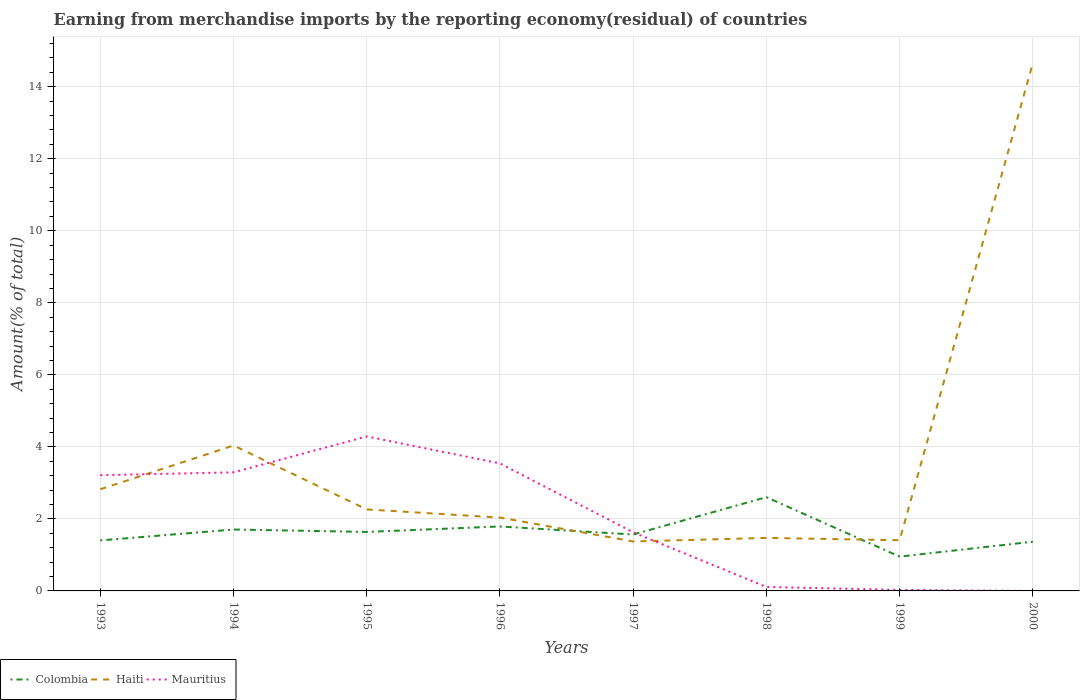How many different coloured lines are there?
Ensure brevity in your answer.  3. Is the number of lines equal to the number of legend labels?
Your response must be concise. Yes. Across all years, what is the maximum percentage of amount earned from merchandise imports in Haiti?
Provide a succinct answer. 1.37. What is the total percentage of amount earned from merchandise imports in Colombia in the graph?
Keep it short and to the point. -1.04. What is the difference between the highest and the second highest percentage of amount earned from merchandise imports in Colombia?
Offer a very short reply. 1.65. What is the difference between the highest and the lowest percentage of amount earned from merchandise imports in Haiti?
Provide a short and direct response. 2. How many years are there in the graph?
Provide a short and direct response. 8. Does the graph contain grids?
Make the answer very short. Yes. Where does the legend appear in the graph?
Your answer should be compact. Bottom left. How many legend labels are there?
Give a very brief answer. 3. How are the legend labels stacked?
Give a very brief answer. Horizontal. What is the title of the graph?
Ensure brevity in your answer.  Earning from merchandise imports by the reporting economy(residual) of countries. What is the label or title of the X-axis?
Your answer should be very brief. Years. What is the label or title of the Y-axis?
Your response must be concise. Amount(% of total). What is the Amount(% of total) in Colombia in 1993?
Your response must be concise. 1.4. What is the Amount(% of total) of Haiti in 1993?
Offer a terse response. 2.82. What is the Amount(% of total) of Mauritius in 1993?
Give a very brief answer. 3.21. What is the Amount(% of total) of Colombia in 1994?
Give a very brief answer. 1.71. What is the Amount(% of total) of Haiti in 1994?
Your answer should be compact. 4.04. What is the Amount(% of total) of Mauritius in 1994?
Offer a very short reply. 3.29. What is the Amount(% of total) of Colombia in 1995?
Keep it short and to the point. 1.64. What is the Amount(% of total) of Haiti in 1995?
Ensure brevity in your answer.  2.26. What is the Amount(% of total) of Mauritius in 1995?
Ensure brevity in your answer.  4.29. What is the Amount(% of total) in Colombia in 1996?
Your answer should be compact. 1.79. What is the Amount(% of total) in Haiti in 1996?
Give a very brief answer. 2.04. What is the Amount(% of total) of Mauritius in 1996?
Keep it short and to the point. 3.54. What is the Amount(% of total) of Colombia in 1997?
Make the answer very short. 1.57. What is the Amount(% of total) of Haiti in 1997?
Offer a very short reply. 1.37. What is the Amount(% of total) of Mauritius in 1997?
Give a very brief answer. 1.63. What is the Amount(% of total) of Colombia in 1998?
Your answer should be compact. 2.6. What is the Amount(% of total) in Haiti in 1998?
Your answer should be very brief. 1.47. What is the Amount(% of total) of Mauritius in 1998?
Provide a short and direct response. 0.11. What is the Amount(% of total) of Colombia in 1999?
Provide a succinct answer. 0.95. What is the Amount(% of total) of Haiti in 1999?
Make the answer very short. 1.41. What is the Amount(% of total) in Mauritius in 1999?
Your answer should be compact. 0.03. What is the Amount(% of total) of Colombia in 2000?
Your answer should be very brief. 1.37. What is the Amount(% of total) of Haiti in 2000?
Your answer should be compact. 14.66. What is the Amount(% of total) of Mauritius in 2000?
Your response must be concise. 0. Across all years, what is the maximum Amount(% of total) of Colombia?
Your answer should be compact. 2.6. Across all years, what is the maximum Amount(% of total) in Haiti?
Your response must be concise. 14.66. Across all years, what is the maximum Amount(% of total) of Mauritius?
Offer a terse response. 4.29. Across all years, what is the minimum Amount(% of total) of Colombia?
Your response must be concise. 0.95. Across all years, what is the minimum Amount(% of total) in Haiti?
Offer a terse response. 1.37. Across all years, what is the minimum Amount(% of total) in Mauritius?
Offer a terse response. 0. What is the total Amount(% of total) in Colombia in the graph?
Your answer should be very brief. 13.02. What is the total Amount(% of total) in Haiti in the graph?
Your answer should be compact. 30.07. What is the total Amount(% of total) of Mauritius in the graph?
Ensure brevity in your answer.  16.1. What is the difference between the Amount(% of total) of Colombia in 1993 and that in 1994?
Give a very brief answer. -0.3. What is the difference between the Amount(% of total) in Haiti in 1993 and that in 1994?
Make the answer very short. -1.22. What is the difference between the Amount(% of total) of Mauritius in 1993 and that in 1994?
Your response must be concise. -0.08. What is the difference between the Amount(% of total) of Colombia in 1993 and that in 1995?
Make the answer very short. -0.24. What is the difference between the Amount(% of total) of Haiti in 1993 and that in 1995?
Offer a very short reply. 0.56. What is the difference between the Amount(% of total) of Mauritius in 1993 and that in 1995?
Your answer should be very brief. -1.08. What is the difference between the Amount(% of total) in Colombia in 1993 and that in 1996?
Provide a short and direct response. -0.39. What is the difference between the Amount(% of total) of Haiti in 1993 and that in 1996?
Provide a succinct answer. 0.79. What is the difference between the Amount(% of total) in Mauritius in 1993 and that in 1996?
Ensure brevity in your answer.  -0.33. What is the difference between the Amount(% of total) in Colombia in 1993 and that in 1997?
Offer a terse response. -0.16. What is the difference between the Amount(% of total) in Haiti in 1993 and that in 1997?
Give a very brief answer. 1.45. What is the difference between the Amount(% of total) of Mauritius in 1993 and that in 1997?
Give a very brief answer. 1.59. What is the difference between the Amount(% of total) of Colombia in 1993 and that in 1998?
Your answer should be very brief. -1.2. What is the difference between the Amount(% of total) of Haiti in 1993 and that in 1998?
Offer a terse response. 1.35. What is the difference between the Amount(% of total) of Mauritius in 1993 and that in 1998?
Offer a terse response. 3.1. What is the difference between the Amount(% of total) in Colombia in 1993 and that in 1999?
Your answer should be very brief. 0.45. What is the difference between the Amount(% of total) in Haiti in 1993 and that in 1999?
Your answer should be compact. 1.42. What is the difference between the Amount(% of total) in Mauritius in 1993 and that in 1999?
Your answer should be very brief. 3.19. What is the difference between the Amount(% of total) in Colombia in 1993 and that in 2000?
Your answer should be very brief. 0.04. What is the difference between the Amount(% of total) in Haiti in 1993 and that in 2000?
Ensure brevity in your answer.  -11.84. What is the difference between the Amount(% of total) of Mauritius in 1993 and that in 2000?
Your answer should be compact. 3.21. What is the difference between the Amount(% of total) of Colombia in 1994 and that in 1995?
Ensure brevity in your answer.  0.07. What is the difference between the Amount(% of total) of Haiti in 1994 and that in 1995?
Keep it short and to the point. 1.78. What is the difference between the Amount(% of total) of Mauritius in 1994 and that in 1995?
Ensure brevity in your answer.  -1. What is the difference between the Amount(% of total) of Colombia in 1994 and that in 1996?
Provide a short and direct response. -0.08. What is the difference between the Amount(% of total) of Haiti in 1994 and that in 1996?
Keep it short and to the point. 2. What is the difference between the Amount(% of total) of Mauritius in 1994 and that in 1996?
Give a very brief answer. -0.25. What is the difference between the Amount(% of total) in Colombia in 1994 and that in 1997?
Provide a short and direct response. 0.14. What is the difference between the Amount(% of total) in Haiti in 1994 and that in 1997?
Provide a short and direct response. 2.67. What is the difference between the Amount(% of total) in Mauritius in 1994 and that in 1997?
Make the answer very short. 1.66. What is the difference between the Amount(% of total) of Colombia in 1994 and that in 1998?
Offer a very short reply. -0.9. What is the difference between the Amount(% of total) in Haiti in 1994 and that in 1998?
Keep it short and to the point. 2.57. What is the difference between the Amount(% of total) of Mauritius in 1994 and that in 1998?
Provide a succinct answer. 3.18. What is the difference between the Amount(% of total) in Colombia in 1994 and that in 1999?
Keep it short and to the point. 0.75. What is the difference between the Amount(% of total) in Haiti in 1994 and that in 1999?
Offer a very short reply. 2.63. What is the difference between the Amount(% of total) of Mauritius in 1994 and that in 1999?
Make the answer very short. 3.26. What is the difference between the Amount(% of total) of Colombia in 1994 and that in 2000?
Offer a terse response. 0.34. What is the difference between the Amount(% of total) of Haiti in 1994 and that in 2000?
Your response must be concise. -10.62. What is the difference between the Amount(% of total) of Mauritius in 1994 and that in 2000?
Give a very brief answer. 3.29. What is the difference between the Amount(% of total) in Colombia in 1995 and that in 1996?
Ensure brevity in your answer.  -0.15. What is the difference between the Amount(% of total) in Haiti in 1995 and that in 1996?
Offer a terse response. 0.23. What is the difference between the Amount(% of total) of Mauritius in 1995 and that in 1996?
Offer a very short reply. 0.75. What is the difference between the Amount(% of total) in Colombia in 1995 and that in 1997?
Provide a short and direct response. 0.07. What is the difference between the Amount(% of total) in Haiti in 1995 and that in 1997?
Offer a terse response. 0.89. What is the difference between the Amount(% of total) of Mauritius in 1995 and that in 1997?
Keep it short and to the point. 2.66. What is the difference between the Amount(% of total) of Colombia in 1995 and that in 1998?
Your response must be concise. -0.96. What is the difference between the Amount(% of total) of Haiti in 1995 and that in 1998?
Make the answer very short. 0.79. What is the difference between the Amount(% of total) in Mauritius in 1995 and that in 1998?
Your answer should be very brief. 4.18. What is the difference between the Amount(% of total) of Colombia in 1995 and that in 1999?
Offer a very short reply. 0.69. What is the difference between the Amount(% of total) in Haiti in 1995 and that in 1999?
Your response must be concise. 0.85. What is the difference between the Amount(% of total) in Mauritius in 1995 and that in 1999?
Offer a terse response. 4.26. What is the difference between the Amount(% of total) in Colombia in 1995 and that in 2000?
Keep it short and to the point. 0.27. What is the difference between the Amount(% of total) in Haiti in 1995 and that in 2000?
Your response must be concise. -12.4. What is the difference between the Amount(% of total) of Mauritius in 1995 and that in 2000?
Your response must be concise. 4.29. What is the difference between the Amount(% of total) of Colombia in 1996 and that in 1997?
Your answer should be very brief. 0.22. What is the difference between the Amount(% of total) in Haiti in 1996 and that in 1997?
Your response must be concise. 0.66. What is the difference between the Amount(% of total) in Mauritius in 1996 and that in 1997?
Offer a terse response. 1.91. What is the difference between the Amount(% of total) of Colombia in 1996 and that in 1998?
Ensure brevity in your answer.  -0.81. What is the difference between the Amount(% of total) of Haiti in 1996 and that in 1998?
Offer a terse response. 0.56. What is the difference between the Amount(% of total) of Mauritius in 1996 and that in 1998?
Offer a very short reply. 3.43. What is the difference between the Amount(% of total) of Colombia in 1996 and that in 1999?
Your response must be concise. 0.84. What is the difference between the Amount(% of total) in Haiti in 1996 and that in 1999?
Keep it short and to the point. 0.63. What is the difference between the Amount(% of total) in Mauritius in 1996 and that in 1999?
Make the answer very short. 3.51. What is the difference between the Amount(% of total) of Colombia in 1996 and that in 2000?
Your answer should be very brief. 0.42. What is the difference between the Amount(% of total) in Haiti in 1996 and that in 2000?
Provide a short and direct response. -12.62. What is the difference between the Amount(% of total) of Mauritius in 1996 and that in 2000?
Make the answer very short. 3.54. What is the difference between the Amount(% of total) in Colombia in 1997 and that in 1998?
Provide a short and direct response. -1.04. What is the difference between the Amount(% of total) in Haiti in 1997 and that in 1998?
Your response must be concise. -0.1. What is the difference between the Amount(% of total) in Mauritius in 1997 and that in 1998?
Keep it short and to the point. 1.52. What is the difference between the Amount(% of total) in Colombia in 1997 and that in 1999?
Ensure brevity in your answer.  0.61. What is the difference between the Amount(% of total) in Haiti in 1997 and that in 1999?
Provide a succinct answer. -0.03. What is the difference between the Amount(% of total) in Mauritius in 1997 and that in 1999?
Your answer should be compact. 1.6. What is the difference between the Amount(% of total) in Colombia in 1997 and that in 2000?
Your answer should be very brief. 0.2. What is the difference between the Amount(% of total) of Haiti in 1997 and that in 2000?
Your response must be concise. -13.29. What is the difference between the Amount(% of total) in Mauritius in 1997 and that in 2000?
Keep it short and to the point. 1.63. What is the difference between the Amount(% of total) of Colombia in 1998 and that in 1999?
Give a very brief answer. 1.65. What is the difference between the Amount(% of total) of Haiti in 1998 and that in 1999?
Provide a short and direct response. 0.06. What is the difference between the Amount(% of total) of Mauritius in 1998 and that in 1999?
Provide a short and direct response. 0.08. What is the difference between the Amount(% of total) of Colombia in 1998 and that in 2000?
Keep it short and to the point. 1.24. What is the difference between the Amount(% of total) of Haiti in 1998 and that in 2000?
Give a very brief answer. -13.19. What is the difference between the Amount(% of total) of Mauritius in 1998 and that in 2000?
Give a very brief answer. 0.11. What is the difference between the Amount(% of total) of Colombia in 1999 and that in 2000?
Your answer should be compact. -0.41. What is the difference between the Amount(% of total) in Haiti in 1999 and that in 2000?
Ensure brevity in your answer.  -13.25. What is the difference between the Amount(% of total) in Mauritius in 1999 and that in 2000?
Keep it short and to the point. 0.03. What is the difference between the Amount(% of total) in Colombia in 1993 and the Amount(% of total) in Haiti in 1994?
Keep it short and to the point. -2.64. What is the difference between the Amount(% of total) in Colombia in 1993 and the Amount(% of total) in Mauritius in 1994?
Your answer should be compact. -1.89. What is the difference between the Amount(% of total) in Haiti in 1993 and the Amount(% of total) in Mauritius in 1994?
Keep it short and to the point. -0.47. What is the difference between the Amount(% of total) of Colombia in 1993 and the Amount(% of total) of Haiti in 1995?
Make the answer very short. -0.86. What is the difference between the Amount(% of total) of Colombia in 1993 and the Amount(% of total) of Mauritius in 1995?
Make the answer very short. -2.89. What is the difference between the Amount(% of total) of Haiti in 1993 and the Amount(% of total) of Mauritius in 1995?
Offer a very short reply. -1.47. What is the difference between the Amount(% of total) of Colombia in 1993 and the Amount(% of total) of Haiti in 1996?
Offer a terse response. -0.63. What is the difference between the Amount(% of total) of Colombia in 1993 and the Amount(% of total) of Mauritius in 1996?
Ensure brevity in your answer.  -2.14. What is the difference between the Amount(% of total) of Haiti in 1993 and the Amount(% of total) of Mauritius in 1996?
Offer a terse response. -0.72. What is the difference between the Amount(% of total) in Colombia in 1993 and the Amount(% of total) in Haiti in 1997?
Your answer should be compact. 0.03. What is the difference between the Amount(% of total) of Colombia in 1993 and the Amount(% of total) of Mauritius in 1997?
Make the answer very short. -0.23. What is the difference between the Amount(% of total) in Haiti in 1993 and the Amount(% of total) in Mauritius in 1997?
Your response must be concise. 1.2. What is the difference between the Amount(% of total) of Colombia in 1993 and the Amount(% of total) of Haiti in 1998?
Offer a very short reply. -0.07. What is the difference between the Amount(% of total) of Colombia in 1993 and the Amount(% of total) of Mauritius in 1998?
Keep it short and to the point. 1.29. What is the difference between the Amount(% of total) of Haiti in 1993 and the Amount(% of total) of Mauritius in 1998?
Offer a very short reply. 2.71. What is the difference between the Amount(% of total) of Colombia in 1993 and the Amount(% of total) of Haiti in 1999?
Your response must be concise. -0.01. What is the difference between the Amount(% of total) of Colombia in 1993 and the Amount(% of total) of Mauritius in 1999?
Make the answer very short. 1.37. What is the difference between the Amount(% of total) in Haiti in 1993 and the Amount(% of total) in Mauritius in 1999?
Offer a very short reply. 2.79. What is the difference between the Amount(% of total) of Colombia in 1993 and the Amount(% of total) of Haiti in 2000?
Your response must be concise. -13.26. What is the difference between the Amount(% of total) in Colombia in 1993 and the Amount(% of total) in Mauritius in 2000?
Offer a very short reply. 1.4. What is the difference between the Amount(% of total) in Haiti in 1993 and the Amount(% of total) in Mauritius in 2000?
Provide a succinct answer. 2.82. What is the difference between the Amount(% of total) in Colombia in 1994 and the Amount(% of total) in Haiti in 1995?
Offer a very short reply. -0.56. What is the difference between the Amount(% of total) of Colombia in 1994 and the Amount(% of total) of Mauritius in 1995?
Offer a very short reply. -2.58. What is the difference between the Amount(% of total) of Haiti in 1994 and the Amount(% of total) of Mauritius in 1995?
Ensure brevity in your answer.  -0.25. What is the difference between the Amount(% of total) in Colombia in 1994 and the Amount(% of total) in Haiti in 1996?
Offer a terse response. -0.33. What is the difference between the Amount(% of total) in Colombia in 1994 and the Amount(% of total) in Mauritius in 1996?
Keep it short and to the point. -1.84. What is the difference between the Amount(% of total) of Haiti in 1994 and the Amount(% of total) of Mauritius in 1996?
Your response must be concise. 0.5. What is the difference between the Amount(% of total) of Colombia in 1994 and the Amount(% of total) of Haiti in 1997?
Keep it short and to the point. 0.33. What is the difference between the Amount(% of total) of Colombia in 1994 and the Amount(% of total) of Mauritius in 1997?
Your answer should be very brief. 0.08. What is the difference between the Amount(% of total) of Haiti in 1994 and the Amount(% of total) of Mauritius in 1997?
Ensure brevity in your answer.  2.41. What is the difference between the Amount(% of total) of Colombia in 1994 and the Amount(% of total) of Haiti in 1998?
Ensure brevity in your answer.  0.23. What is the difference between the Amount(% of total) of Colombia in 1994 and the Amount(% of total) of Mauritius in 1998?
Provide a short and direct response. 1.6. What is the difference between the Amount(% of total) of Haiti in 1994 and the Amount(% of total) of Mauritius in 1998?
Provide a short and direct response. 3.93. What is the difference between the Amount(% of total) of Colombia in 1994 and the Amount(% of total) of Haiti in 1999?
Offer a very short reply. 0.3. What is the difference between the Amount(% of total) of Colombia in 1994 and the Amount(% of total) of Mauritius in 1999?
Your answer should be compact. 1.68. What is the difference between the Amount(% of total) of Haiti in 1994 and the Amount(% of total) of Mauritius in 1999?
Provide a short and direct response. 4.01. What is the difference between the Amount(% of total) of Colombia in 1994 and the Amount(% of total) of Haiti in 2000?
Provide a succinct answer. -12.95. What is the difference between the Amount(% of total) in Colombia in 1994 and the Amount(% of total) in Mauritius in 2000?
Your answer should be compact. 1.7. What is the difference between the Amount(% of total) of Haiti in 1994 and the Amount(% of total) of Mauritius in 2000?
Ensure brevity in your answer.  4.04. What is the difference between the Amount(% of total) in Colombia in 1995 and the Amount(% of total) in Haiti in 1996?
Your response must be concise. -0.4. What is the difference between the Amount(% of total) in Colombia in 1995 and the Amount(% of total) in Mauritius in 1996?
Make the answer very short. -1.9. What is the difference between the Amount(% of total) of Haiti in 1995 and the Amount(% of total) of Mauritius in 1996?
Your answer should be compact. -1.28. What is the difference between the Amount(% of total) of Colombia in 1995 and the Amount(% of total) of Haiti in 1997?
Provide a succinct answer. 0.27. What is the difference between the Amount(% of total) of Colombia in 1995 and the Amount(% of total) of Mauritius in 1997?
Keep it short and to the point. 0.01. What is the difference between the Amount(% of total) of Haiti in 1995 and the Amount(% of total) of Mauritius in 1997?
Provide a short and direct response. 0.63. What is the difference between the Amount(% of total) of Colombia in 1995 and the Amount(% of total) of Haiti in 1998?
Give a very brief answer. 0.17. What is the difference between the Amount(% of total) of Colombia in 1995 and the Amount(% of total) of Mauritius in 1998?
Your response must be concise. 1.53. What is the difference between the Amount(% of total) in Haiti in 1995 and the Amount(% of total) in Mauritius in 1998?
Ensure brevity in your answer.  2.15. What is the difference between the Amount(% of total) of Colombia in 1995 and the Amount(% of total) of Haiti in 1999?
Give a very brief answer. 0.23. What is the difference between the Amount(% of total) of Colombia in 1995 and the Amount(% of total) of Mauritius in 1999?
Make the answer very short. 1.61. What is the difference between the Amount(% of total) of Haiti in 1995 and the Amount(% of total) of Mauritius in 1999?
Give a very brief answer. 2.23. What is the difference between the Amount(% of total) of Colombia in 1995 and the Amount(% of total) of Haiti in 2000?
Provide a short and direct response. -13.02. What is the difference between the Amount(% of total) of Colombia in 1995 and the Amount(% of total) of Mauritius in 2000?
Provide a succinct answer. 1.64. What is the difference between the Amount(% of total) in Haiti in 1995 and the Amount(% of total) in Mauritius in 2000?
Offer a terse response. 2.26. What is the difference between the Amount(% of total) of Colombia in 1996 and the Amount(% of total) of Haiti in 1997?
Ensure brevity in your answer.  0.42. What is the difference between the Amount(% of total) in Colombia in 1996 and the Amount(% of total) in Mauritius in 1997?
Ensure brevity in your answer.  0.16. What is the difference between the Amount(% of total) of Haiti in 1996 and the Amount(% of total) of Mauritius in 1997?
Your answer should be compact. 0.41. What is the difference between the Amount(% of total) of Colombia in 1996 and the Amount(% of total) of Haiti in 1998?
Provide a succinct answer. 0.32. What is the difference between the Amount(% of total) of Colombia in 1996 and the Amount(% of total) of Mauritius in 1998?
Your response must be concise. 1.68. What is the difference between the Amount(% of total) in Haiti in 1996 and the Amount(% of total) in Mauritius in 1998?
Provide a succinct answer. 1.93. What is the difference between the Amount(% of total) in Colombia in 1996 and the Amount(% of total) in Haiti in 1999?
Ensure brevity in your answer.  0.38. What is the difference between the Amount(% of total) of Colombia in 1996 and the Amount(% of total) of Mauritius in 1999?
Provide a short and direct response. 1.76. What is the difference between the Amount(% of total) in Haiti in 1996 and the Amount(% of total) in Mauritius in 1999?
Keep it short and to the point. 2.01. What is the difference between the Amount(% of total) of Colombia in 1996 and the Amount(% of total) of Haiti in 2000?
Offer a very short reply. -12.87. What is the difference between the Amount(% of total) in Colombia in 1996 and the Amount(% of total) in Mauritius in 2000?
Give a very brief answer. 1.79. What is the difference between the Amount(% of total) in Haiti in 1996 and the Amount(% of total) in Mauritius in 2000?
Ensure brevity in your answer.  2.03. What is the difference between the Amount(% of total) in Colombia in 1997 and the Amount(% of total) in Haiti in 1998?
Offer a very short reply. 0.09. What is the difference between the Amount(% of total) of Colombia in 1997 and the Amount(% of total) of Mauritius in 1998?
Your response must be concise. 1.46. What is the difference between the Amount(% of total) in Haiti in 1997 and the Amount(% of total) in Mauritius in 1998?
Give a very brief answer. 1.26. What is the difference between the Amount(% of total) of Colombia in 1997 and the Amount(% of total) of Haiti in 1999?
Provide a short and direct response. 0.16. What is the difference between the Amount(% of total) in Colombia in 1997 and the Amount(% of total) in Mauritius in 1999?
Your answer should be very brief. 1.54. What is the difference between the Amount(% of total) in Haiti in 1997 and the Amount(% of total) in Mauritius in 1999?
Ensure brevity in your answer.  1.34. What is the difference between the Amount(% of total) of Colombia in 1997 and the Amount(% of total) of Haiti in 2000?
Make the answer very short. -13.09. What is the difference between the Amount(% of total) of Colombia in 1997 and the Amount(% of total) of Mauritius in 2000?
Make the answer very short. 1.56. What is the difference between the Amount(% of total) in Haiti in 1997 and the Amount(% of total) in Mauritius in 2000?
Give a very brief answer. 1.37. What is the difference between the Amount(% of total) in Colombia in 1998 and the Amount(% of total) in Haiti in 1999?
Offer a terse response. 1.19. What is the difference between the Amount(% of total) of Colombia in 1998 and the Amount(% of total) of Mauritius in 1999?
Offer a terse response. 2.57. What is the difference between the Amount(% of total) in Haiti in 1998 and the Amount(% of total) in Mauritius in 1999?
Provide a succinct answer. 1.44. What is the difference between the Amount(% of total) of Colombia in 1998 and the Amount(% of total) of Haiti in 2000?
Your response must be concise. -12.06. What is the difference between the Amount(% of total) of Colombia in 1998 and the Amount(% of total) of Mauritius in 2000?
Ensure brevity in your answer.  2.6. What is the difference between the Amount(% of total) of Haiti in 1998 and the Amount(% of total) of Mauritius in 2000?
Offer a very short reply. 1.47. What is the difference between the Amount(% of total) of Colombia in 1999 and the Amount(% of total) of Haiti in 2000?
Your answer should be very brief. -13.71. What is the difference between the Amount(% of total) in Colombia in 1999 and the Amount(% of total) in Mauritius in 2000?
Provide a short and direct response. 0.95. What is the difference between the Amount(% of total) of Haiti in 1999 and the Amount(% of total) of Mauritius in 2000?
Make the answer very short. 1.41. What is the average Amount(% of total) in Colombia per year?
Give a very brief answer. 1.63. What is the average Amount(% of total) of Haiti per year?
Provide a short and direct response. 3.76. What is the average Amount(% of total) of Mauritius per year?
Offer a terse response. 2.01. In the year 1993, what is the difference between the Amount(% of total) of Colombia and Amount(% of total) of Haiti?
Your response must be concise. -1.42. In the year 1993, what is the difference between the Amount(% of total) in Colombia and Amount(% of total) in Mauritius?
Your answer should be compact. -1.81. In the year 1993, what is the difference between the Amount(% of total) in Haiti and Amount(% of total) in Mauritius?
Make the answer very short. -0.39. In the year 1994, what is the difference between the Amount(% of total) in Colombia and Amount(% of total) in Haiti?
Keep it short and to the point. -2.33. In the year 1994, what is the difference between the Amount(% of total) in Colombia and Amount(% of total) in Mauritius?
Provide a short and direct response. -1.59. In the year 1994, what is the difference between the Amount(% of total) in Haiti and Amount(% of total) in Mauritius?
Keep it short and to the point. 0.75. In the year 1995, what is the difference between the Amount(% of total) in Colombia and Amount(% of total) in Haiti?
Keep it short and to the point. -0.62. In the year 1995, what is the difference between the Amount(% of total) of Colombia and Amount(% of total) of Mauritius?
Your answer should be very brief. -2.65. In the year 1995, what is the difference between the Amount(% of total) in Haiti and Amount(% of total) in Mauritius?
Your answer should be compact. -2.03. In the year 1996, what is the difference between the Amount(% of total) of Colombia and Amount(% of total) of Haiti?
Your answer should be compact. -0.25. In the year 1996, what is the difference between the Amount(% of total) in Colombia and Amount(% of total) in Mauritius?
Your answer should be compact. -1.75. In the year 1996, what is the difference between the Amount(% of total) in Haiti and Amount(% of total) in Mauritius?
Make the answer very short. -1.5. In the year 1997, what is the difference between the Amount(% of total) of Colombia and Amount(% of total) of Haiti?
Your answer should be compact. 0.19. In the year 1997, what is the difference between the Amount(% of total) in Colombia and Amount(% of total) in Mauritius?
Keep it short and to the point. -0.06. In the year 1997, what is the difference between the Amount(% of total) of Haiti and Amount(% of total) of Mauritius?
Your answer should be compact. -0.25. In the year 1998, what is the difference between the Amount(% of total) of Colombia and Amount(% of total) of Haiti?
Your answer should be compact. 1.13. In the year 1998, what is the difference between the Amount(% of total) in Colombia and Amount(% of total) in Mauritius?
Your response must be concise. 2.49. In the year 1998, what is the difference between the Amount(% of total) of Haiti and Amount(% of total) of Mauritius?
Ensure brevity in your answer.  1.36. In the year 1999, what is the difference between the Amount(% of total) in Colombia and Amount(% of total) in Haiti?
Your answer should be compact. -0.46. In the year 1999, what is the difference between the Amount(% of total) in Colombia and Amount(% of total) in Mauritius?
Give a very brief answer. 0.92. In the year 1999, what is the difference between the Amount(% of total) in Haiti and Amount(% of total) in Mauritius?
Provide a succinct answer. 1.38. In the year 2000, what is the difference between the Amount(% of total) of Colombia and Amount(% of total) of Haiti?
Your answer should be very brief. -13.29. In the year 2000, what is the difference between the Amount(% of total) of Colombia and Amount(% of total) of Mauritius?
Give a very brief answer. 1.37. In the year 2000, what is the difference between the Amount(% of total) in Haiti and Amount(% of total) in Mauritius?
Ensure brevity in your answer.  14.66. What is the ratio of the Amount(% of total) of Colombia in 1993 to that in 1994?
Offer a terse response. 0.82. What is the ratio of the Amount(% of total) of Haiti in 1993 to that in 1994?
Offer a very short reply. 0.7. What is the ratio of the Amount(% of total) in Mauritius in 1993 to that in 1994?
Give a very brief answer. 0.98. What is the ratio of the Amount(% of total) of Colombia in 1993 to that in 1995?
Give a very brief answer. 0.86. What is the ratio of the Amount(% of total) in Haiti in 1993 to that in 1995?
Your response must be concise. 1.25. What is the ratio of the Amount(% of total) in Mauritius in 1993 to that in 1995?
Provide a short and direct response. 0.75. What is the ratio of the Amount(% of total) in Colombia in 1993 to that in 1996?
Ensure brevity in your answer.  0.78. What is the ratio of the Amount(% of total) of Haiti in 1993 to that in 1996?
Ensure brevity in your answer.  1.39. What is the ratio of the Amount(% of total) of Mauritius in 1993 to that in 1996?
Make the answer very short. 0.91. What is the ratio of the Amount(% of total) in Colombia in 1993 to that in 1997?
Give a very brief answer. 0.9. What is the ratio of the Amount(% of total) in Haiti in 1993 to that in 1997?
Your response must be concise. 2.06. What is the ratio of the Amount(% of total) in Mauritius in 1993 to that in 1997?
Offer a terse response. 1.97. What is the ratio of the Amount(% of total) in Colombia in 1993 to that in 1998?
Ensure brevity in your answer.  0.54. What is the ratio of the Amount(% of total) of Haiti in 1993 to that in 1998?
Offer a very short reply. 1.92. What is the ratio of the Amount(% of total) of Mauritius in 1993 to that in 1998?
Offer a very short reply. 29.2. What is the ratio of the Amount(% of total) in Colombia in 1993 to that in 1999?
Offer a very short reply. 1.47. What is the ratio of the Amount(% of total) of Haiti in 1993 to that in 1999?
Ensure brevity in your answer.  2. What is the ratio of the Amount(% of total) in Mauritius in 1993 to that in 1999?
Give a very brief answer. 113.75. What is the ratio of the Amount(% of total) in Colombia in 1993 to that in 2000?
Offer a very short reply. 1.03. What is the ratio of the Amount(% of total) in Haiti in 1993 to that in 2000?
Offer a very short reply. 0.19. What is the ratio of the Amount(% of total) in Mauritius in 1993 to that in 2000?
Give a very brief answer. 2172.92. What is the ratio of the Amount(% of total) in Colombia in 1994 to that in 1995?
Your response must be concise. 1.04. What is the ratio of the Amount(% of total) of Haiti in 1994 to that in 1995?
Ensure brevity in your answer.  1.78. What is the ratio of the Amount(% of total) in Mauritius in 1994 to that in 1995?
Provide a short and direct response. 0.77. What is the ratio of the Amount(% of total) in Colombia in 1994 to that in 1996?
Your answer should be very brief. 0.95. What is the ratio of the Amount(% of total) of Haiti in 1994 to that in 1996?
Your answer should be compact. 1.98. What is the ratio of the Amount(% of total) of Mauritius in 1994 to that in 1996?
Your response must be concise. 0.93. What is the ratio of the Amount(% of total) in Colombia in 1994 to that in 1997?
Provide a succinct answer. 1.09. What is the ratio of the Amount(% of total) in Haiti in 1994 to that in 1997?
Your response must be concise. 2.94. What is the ratio of the Amount(% of total) of Mauritius in 1994 to that in 1997?
Your answer should be very brief. 2.02. What is the ratio of the Amount(% of total) in Colombia in 1994 to that in 1998?
Provide a short and direct response. 0.66. What is the ratio of the Amount(% of total) in Haiti in 1994 to that in 1998?
Your response must be concise. 2.74. What is the ratio of the Amount(% of total) of Mauritius in 1994 to that in 1998?
Provide a succinct answer. 29.93. What is the ratio of the Amount(% of total) of Colombia in 1994 to that in 1999?
Provide a short and direct response. 1.79. What is the ratio of the Amount(% of total) in Haiti in 1994 to that in 1999?
Your response must be concise. 2.87. What is the ratio of the Amount(% of total) in Mauritius in 1994 to that in 1999?
Give a very brief answer. 116.57. What is the ratio of the Amount(% of total) of Colombia in 1994 to that in 2000?
Your answer should be very brief. 1.25. What is the ratio of the Amount(% of total) in Haiti in 1994 to that in 2000?
Your response must be concise. 0.28. What is the ratio of the Amount(% of total) in Mauritius in 1994 to that in 2000?
Provide a succinct answer. 2226.84. What is the ratio of the Amount(% of total) in Colombia in 1995 to that in 1996?
Your answer should be compact. 0.92. What is the ratio of the Amount(% of total) of Haiti in 1995 to that in 1996?
Your answer should be compact. 1.11. What is the ratio of the Amount(% of total) of Mauritius in 1995 to that in 1996?
Ensure brevity in your answer.  1.21. What is the ratio of the Amount(% of total) in Colombia in 1995 to that in 1997?
Make the answer very short. 1.05. What is the ratio of the Amount(% of total) in Haiti in 1995 to that in 1997?
Make the answer very short. 1.65. What is the ratio of the Amount(% of total) in Mauritius in 1995 to that in 1997?
Your answer should be compact. 2.63. What is the ratio of the Amount(% of total) in Colombia in 1995 to that in 1998?
Your answer should be very brief. 0.63. What is the ratio of the Amount(% of total) of Haiti in 1995 to that in 1998?
Give a very brief answer. 1.54. What is the ratio of the Amount(% of total) in Mauritius in 1995 to that in 1998?
Make the answer very short. 38.99. What is the ratio of the Amount(% of total) of Colombia in 1995 to that in 1999?
Your response must be concise. 1.72. What is the ratio of the Amount(% of total) of Haiti in 1995 to that in 1999?
Keep it short and to the point. 1.61. What is the ratio of the Amount(% of total) in Mauritius in 1995 to that in 1999?
Give a very brief answer. 151.85. What is the ratio of the Amount(% of total) of Colombia in 1995 to that in 2000?
Make the answer very short. 1.2. What is the ratio of the Amount(% of total) in Haiti in 1995 to that in 2000?
Your answer should be compact. 0.15. What is the ratio of the Amount(% of total) of Mauritius in 1995 to that in 2000?
Make the answer very short. 2900.78. What is the ratio of the Amount(% of total) in Colombia in 1996 to that in 1997?
Your answer should be very brief. 1.14. What is the ratio of the Amount(% of total) in Haiti in 1996 to that in 1997?
Give a very brief answer. 1.48. What is the ratio of the Amount(% of total) of Mauritius in 1996 to that in 1997?
Your response must be concise. 2.17. What is the ratio of the Amount(% of total) of Colombia in 1996 to that in 1998?
Provide a short and direct response. 0.69. What is the ratio of the Amount(% of total) in Haiti in 1996 to that in 1998?
Provide a short and direct response. 1.38. What is the ratio of the Amount(% of total) of Mauritius in 1996 to that in 1998?
Offer a very short reply. 32.18. What is the ratio of the Amount(% of total) of Colombia in 1996 to that in 1999?
Your answer should be compact. 1.88. What is the ratio of the Amount(% of total) of Haiti in 1996 to that in 1999?
Provide a succinct answer. 1.45. What is the ratio of the Amount(% of total) in Mauritius in 1996 to that in 1999?
Offer a very short reply. 125.33. What is the ratio of the Amount(% of total) in Colombia in 1996 to that in 2000?
Give a very brief answer. 1.31. What is the ratio of the Amount(% of total) of Haiti in 1996 to that in 2000?
Provide a succinct answer. 0.14. What is the ratio of the Amount(% of total) in Mauritius in 1996 to that in 2000?
Make the answer very short. 2394.13. What is the ratio of the Amount(% of total) in Colombia in 1997 to that in 1998?
Provide a succinct answer. 0.6. What is the ratio of the Amount(% of total) in Haiti in 1997 to that in 1998?
Offer a very short reply. 0.93. What is the ratio of the Amount(% of total) in Mauritius in 1997 to that in 1998?
Give a very brief answer. 14.8. What is the ratio of the Amount(% of total) of Colombia in 1997 to that in 1999?
Give a very brief answer. 1.64. What is the ratio of the Amount(% of total) of Haiti in 1997 to that in 1999?
Keep it short and to the point. 0.98. What is the ratio of the Amount(% of total) in Mauritius in 1997 to that in 1999?
Make the answer very short. 57.64. What is the ratio of the Amount(% of total) in Colombia in 1997 to that in 2000?
Your answer should be compact. 1.15. What is the ratio of the Amount(% of total) in Haiti in 1997 to that in 2000?
Offer a terse response. 0.09. What is the ratio of the Amount(% of total) in Mauritius in 1997 to that in 2000?
Ensure brevity in your answer.  1100.99. What is the ratio of the Amount(% of total) of Colombia in 1998 to that in 1999?
Ensure brevity in your answer.  2.73. What is the ratio of the Amount(% of total) of Haiti in 1998 to that in 1999?
Give a very brief answer. 1.05. What is the ratio of the Amount(% of total) in Mauritius in 1998 to that in 1999?
Your answer should be very brief. 3.9. What is the ratio of the Amount(% of total) of Colombia in 1998 to that in 2000?
Your answer should be compact. 1.9. What is the ratio of the Amount(% of total) of Haiti in 1998 to that in 2000?
Offer a terse response. 0.1. What is the ratio of the Amount(% of total) of Mauritius in 1998 to that in 2000?
Ensure brevity in your answer.  74.41. What is the ratio of the Amount(% of total) of Colombia in 1999 to that in 2000?
Provide a short and direct response. 0.7. What is the ratio of the Amount(% of total) of Haiti in 1999 to that in 2000?
Ensure brevity in your answer.  0.1. What is the ratio of the Amount(% of total) in Mauritius in 1999 to that in 2000?
Give a very brief answer. 19.1. What is the difference between the highest and the second highest Amount(% of total) in Colombia?
Your response must be concise. 0.81. What is the difference between the highest and the second highest Amount(% of total) of Haiti?
Your answer should be compact. 10.62. What is the difference between the highest and the second highest Amount(% of total) of Mauritius?
Provide a succinct answer. 0.75. What is the difference between the highest and the lowest Amount(% of total) in Colombia?
Keep it short and to the point. 1.65. What is the difference between the highest and the lowest Amount(% of total) of Haiti?
Make the answer very short. 13.29. What is the difference between the highest and the lowest Amount(% of total) in Mauritius?
Offer a terse response. 4.29. 